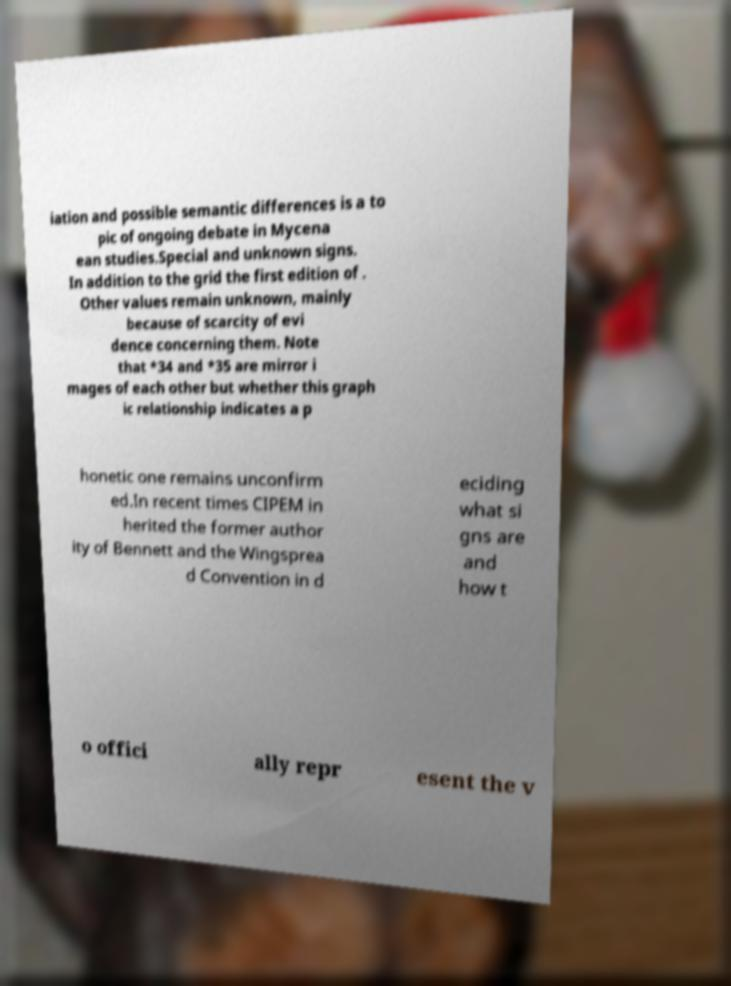Please identify and transcribe the text found in this image. iation and possible semantic differences is a to pic of ongoing debate in Mycena ean studies.Special and unknown signs. In addition to the grid the first edition of . Other values remain unknown, mainly because of scarcity of evi dence concerning them. Note that *34 and *35 are mirror i mages of each other but whether this graph ic relationship indicates a p honetic one remains unconfirm ed.In recent times CIPEM in herited the former author ity of Bennett and the Wingsprea d Convention in d eciding what si gns are and how t o offici ally repr esent the v 